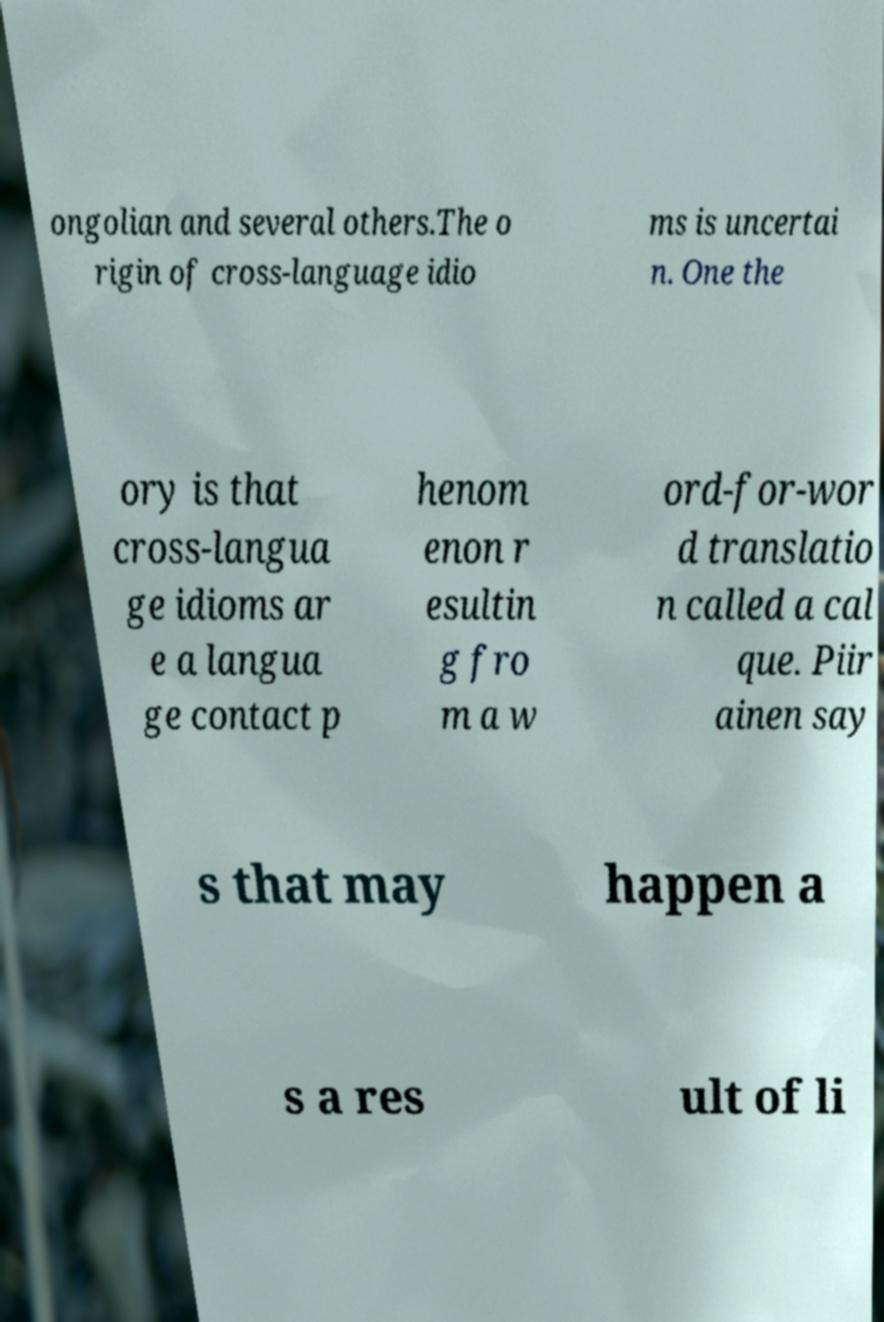What messages or text are displayed in this image? I need them in a readable, typed format. ongolian and several others.The o rigin of cross-language idio ms is uncertai n. One the ory is that cross-langua ge idioms ar e a langua ge contact p henom enon r esultin g fro m a w ord-for-wor d translatio n called a cal que. Piir ainen say s that may happen a s a res ult of li 